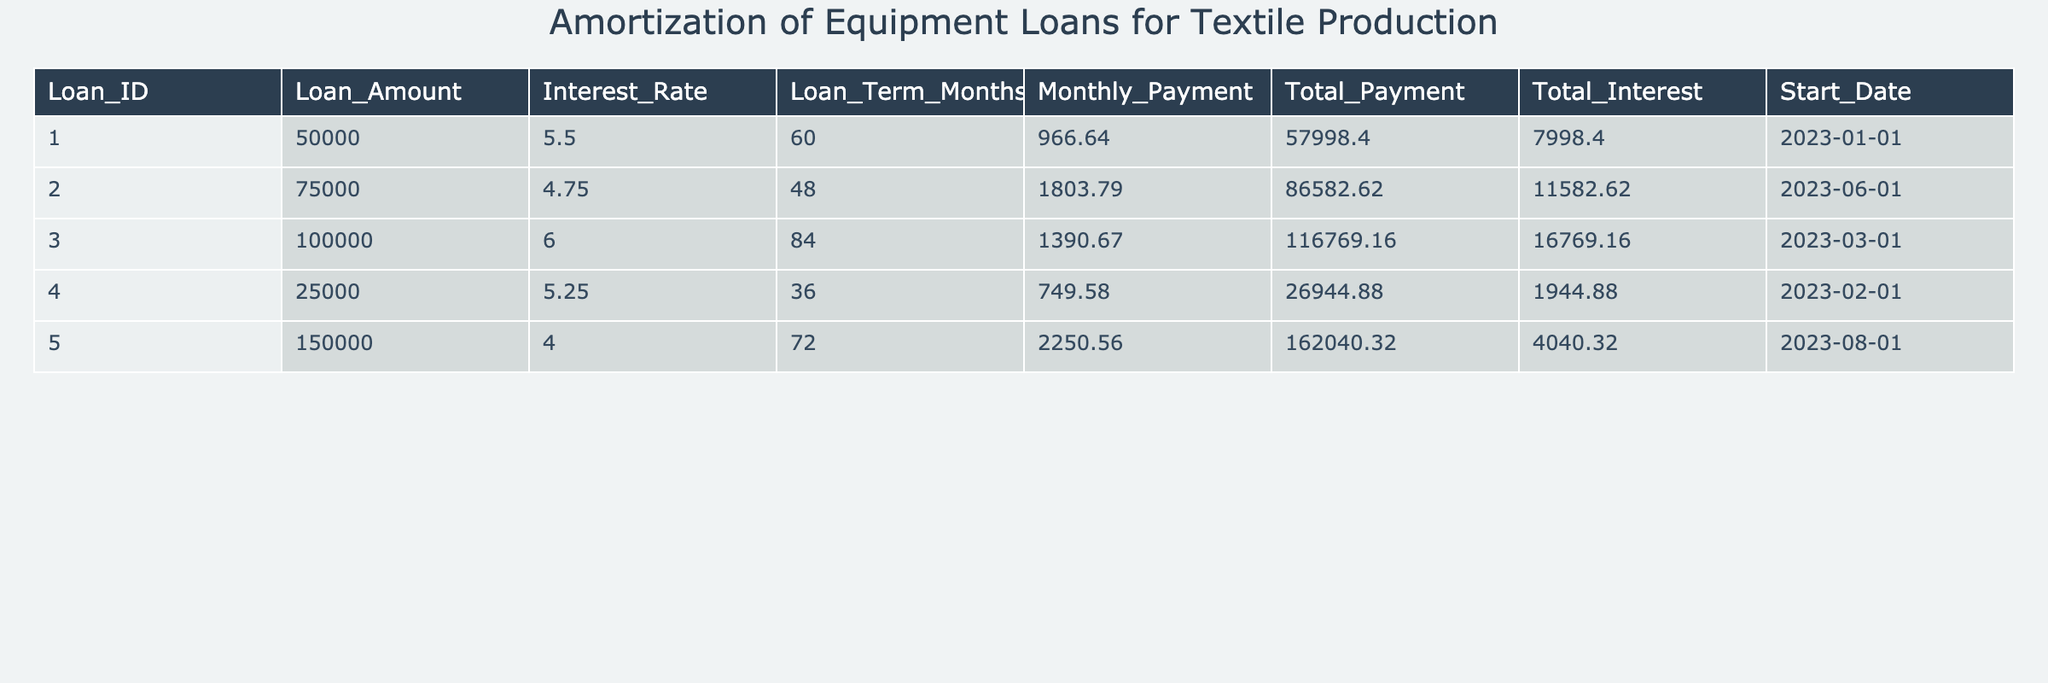What is the loan amount for Loan_ID 002? The loan amount is located in the second column of the table. For Loan_ID 002, the corresponding loan amount is 75000.
Answer: 75000 What is the total interest paid for the equipment loan with the lowest loan amount? To find the equipment loan with the lowest loan amount, we look at the first column. The lowest loan amount is 25000 for Loan_ID 004, which has a total interest of 1944.88.
Answer: 1944.88 Is the monthly payment for Loan_ID 003 greater than 1400? We check the monthly payment for Loan_ID 003, which is 1390.67. Since 1390.67 is less than 1400, the statement is false.
Answer: No What is the difference in total payments between Loan_ID 001 and Loan_ID 005? First, identify the total payment for each loan: Loan_ID 001 has a total payment of 57998.40 and Loan_ID 005 has a total payment of 162040.32. The difference is calculated as 162040.32 - 57998.40 = 104041.92.
Answer: 104041.92 Which loan has the highest interest rate and what is that rate? We examine the interest rates from all loans. Loan_ID 003 has the highest interest rate at 6.0, so it is the one we are looking for.
Answer: 6.0 What is the average loan amount for loans with a loan term of 60 months or more? We look at the loans with a term of 60 months or more, which are Loan_ID 001 (50000), Loan_ID 003 (100000), and Loan_ID 005 (150000). The average is calculated as (50000 + 100000 + 150000) / 3 = 100000.
Answer: 100000 Does Loan_ID 004 have a total payment that is less than 25000? Loan_ID 004 has a total payment of 26944.88. Since this amount is greater than 25000, the answer is false.
Answer: No What is the total interest for loans that have a loan term of 72 months or more? We check the loans with a term of 72 months or more, which are Loan_ID 005 (4040.32) and Loan_ID 003 (16769.16). The total interest is calculated as 4040.32 + 16769.16 = 20809.48.
Answer: 20809.48 